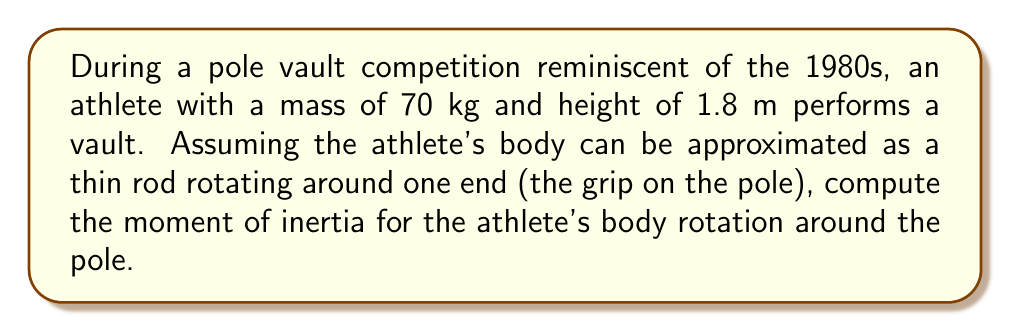Show me your answer to this math problem. To solve this problem, we'll follow these steps:

1) The moment of inertia for a thin rod rotating around one end is given by the formula:

   $$I = \frac{1}{3}mL^2$$

   where $m$ is the mass of the rod and $L$ is its length.

2) In this case:
   $m = 70$ kg (given)
   $L = 1.8$ m (athlete's height)

3) Substituting these values into the formula:

   $$I = \frac{1}{3} \cdot 70 \text{ kg} \cdot (1.8 \text{ m})^2$$

4) Simplify:
   $$I = \frac{1}{3} \cdot 70 \cdot 3.24 \text{ kg}\cdot\text{m}^2$$
   $$I = 75.6 \text{ kg}\cdot\text{m}^2$$

5) Round to three significant figures:
   $$I \approx 75.6 \text{ kg}\cdot\text{m}^2$$

This result represents the moment of inertia of the pole vaulter's body as it rotates around the pole during the vault, reminiscent of the graceful movements observed in past Canadian competitions.
Answer: $75.6 \text{ kg}\cdot\text{m}^2$ 